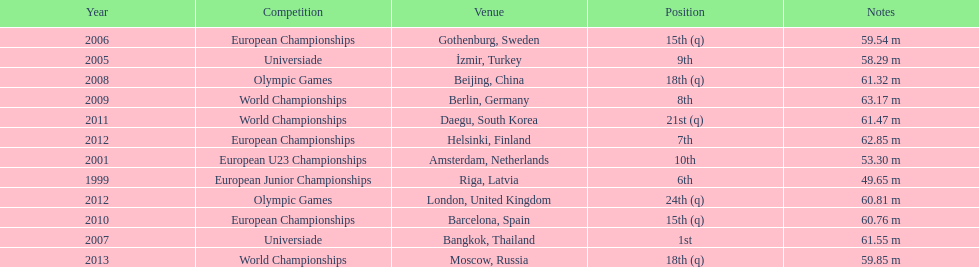How what listed year was a distance of only 53.30m reached? 2001. 